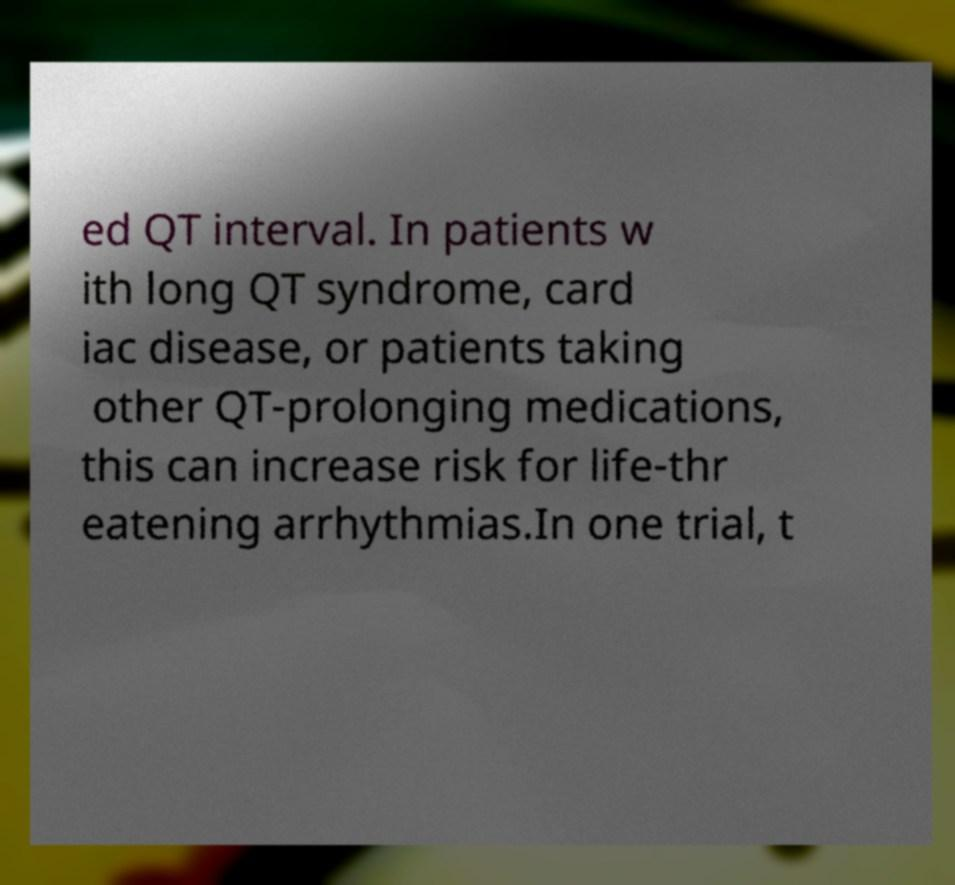There's text embedded in this image that I need extracted. Can you transcribe it verbatim? ed QT interval. In patients w ith long QT syndrome, card iac disease, or patients taking other QT-prolonging medications, this can increase risk for life-thr eatening arrhythmias.In one trial, t 